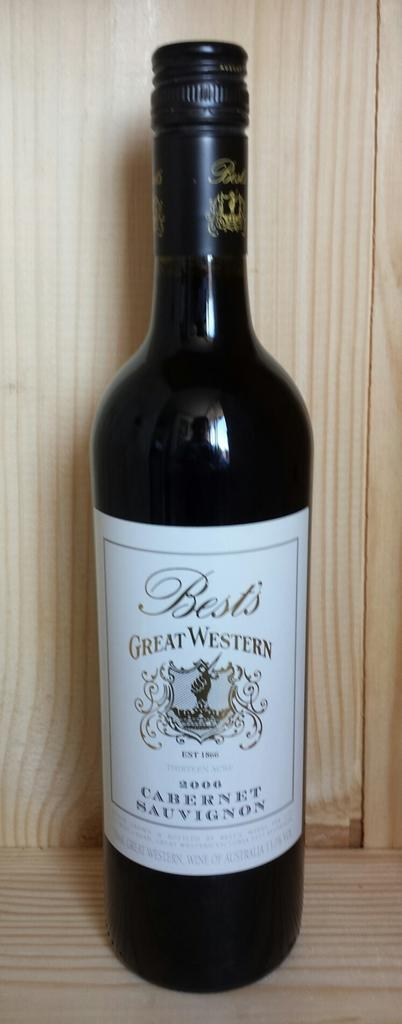<image>
Write a terse but informative summary of the picture. A dark bottle of Best's 2008 wine is displayed on a wooden shelf. 